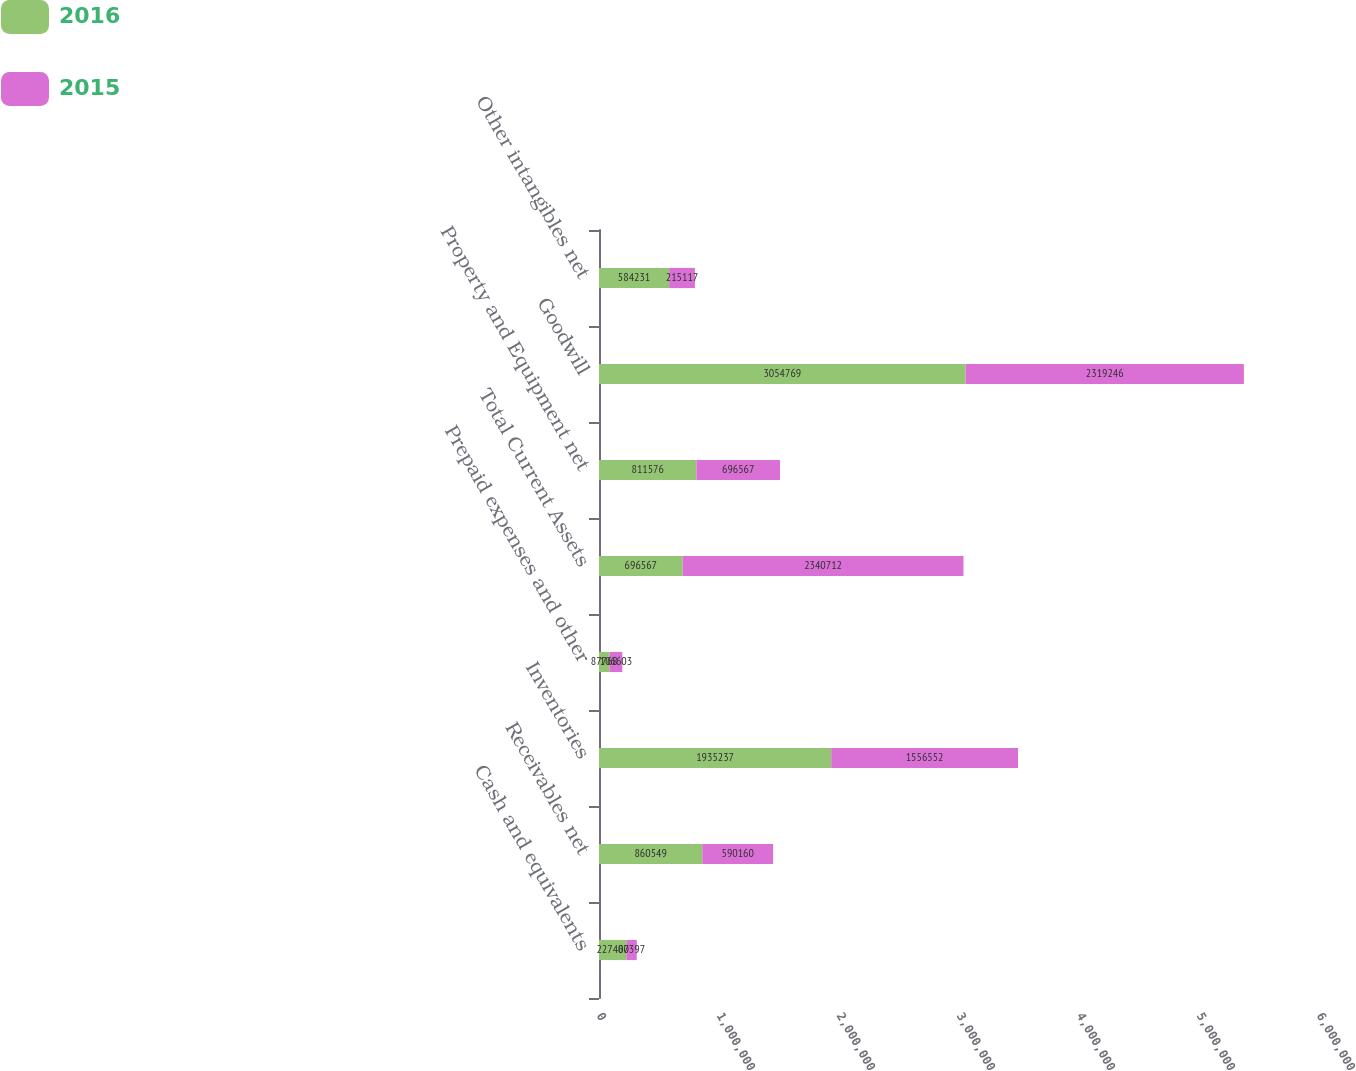<chart> <loc_0><loc_0><loc_500><loc_500><stacked_bar_chart><ecel><fcel>Cash and equivalents<fcel>Receivables net<fcel>Inventories<fcel>Prepaid expenses and other<fcel>Total Current Assets<fcel>Property and Equipment net<fcel>Goodwill<fcel>Other intangibles net<nl><fcel>2016<fcel>227400<fcel>860549<fcel>1.93524e+06<fcel>87768<fcel>696567<fcel>811576<fcel>3.05477e+06<fcel>584231<nl><fcel>2015<fcel>87397<fcel>590160<fcel>1.55655e+06<fcel>106603<fcel>2.34071e+06<fcel>696567<fcel>2.31925e+06<fcel>215117<nl></chart> 